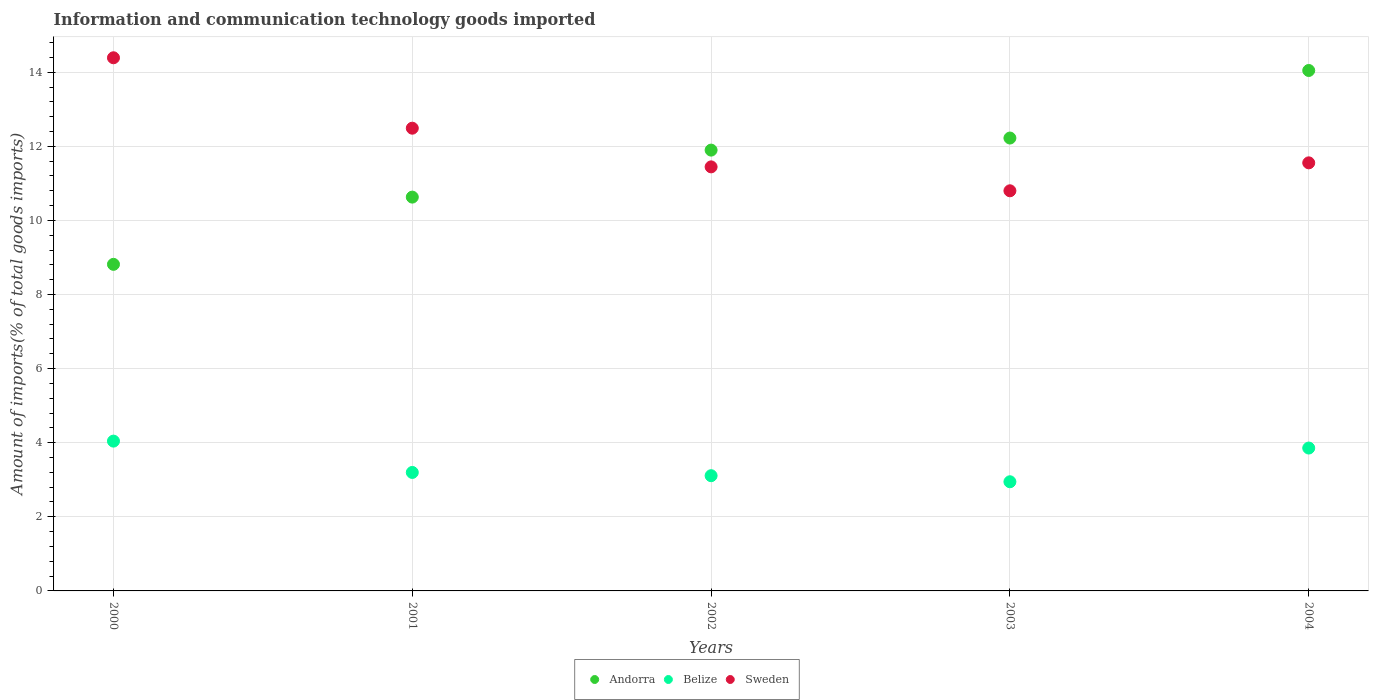Is the number of dotlines equal to the number of legend labels?
Keep it short and to the point. Yes. What is the amount of goods imported in Belize in 2003?
Your response must be concise. 2.95. Across all years, what is the maximum amount of goods imported in Andorra?
Keep it short and to the point. 14.05. Across all years, what is the minimum amount of goods imported in Andorra?
Give a very brief answer. 8.81. In which year was the amount of goods imported in Belize maximum?
Your answer should be compact. 2000. What is the total amount of goods imported in Andorra in the graph?
Your response must be concise. 57.61. What is the difference between the amount of goods imported in Belize in 2000 and that in 2004?
Offer a terse response. 0.19. What is the difference between the amount of goods imported in Belize in 2004 and the amount of goods imported in Andorra in 2000?
Offer a very short reply. -4.96. What is the average amount of goods imported in Andorra per year?
Your answer should be compact. 11.52. In the year 2002, what is the difference between the amount of goods imported in Andorra and amount of goods imported in Sweden?
Your answer should be compact. 0.45. In how many years, is the amount of goods imported in Andorra greater than 3.2 %?
Make the answer very short. 5. What is the ratio of the amount of goods imported in Sweden in 2000 to that in 2003?
Ensure brevity in your answer.  1.33. Is the amount of goods imported in Andorra in 2000 less than that in 2004?
Ensure brevity in your answer.  Yes. What is the difference between the highest and the second highest amount of goods imported in Belize?
Give a very brief answer. 0.19. What is the difference between the highest and the lowest amount of goods imported in Sweden?
Your answer should be very brief. 3.59. Does the amount of goods imported in Sweden monotonically increase over the years?
Make the answer very short. No. Is the amount of goods imported in Belize strictly less than the amount of goods imported in Sweden over the years?
Make the answer very short. Yes. How many dotlines are there?
Your answer should be compact. 3. How many years are there in the graph?
Ensure brevity in your answer.  5. What is the difference between two consecutive major ticks on the Y-axis?
Provide a succinct answer. 2. Are the values on the major ticks of Y-axis written in scientific E-notation?
Offer a terse response. No. Does the graph contain any zero values?
Provide a succinct answer. No. Does the graph contain grids?
Offer a very short reply. Yes. Where does the legend appear in the graph?
Ensure brevity in your answer.  Bottom center. What is the title of the graph?
Provide a succinct answer. Information and communication technology goods imported. What is the label or title of the X-axis?
Your answer should be compact. Years. What is the label or title of the Y-axis?
Your answer should be compact. Amount of imports(% of total goods imports). What is the Amount of imports(% of total goods imports) in Andorra in 2000?
Ensure brevity in your answer.  8.81. What is the Amount of imports(% of total goods imports) of Belize in 2000?
Your answer should be very brief. 4.04. What is the Amount of imports(% of total goods imports) of Sweden in 2000?
Keep it short and to the point. 14.39. What is the Amount of imports(% of total goods imports) in Andorra in 2001?
Keep it short and to the point. 10.63. What is the Amount of imports(% of total goods imports) of Belize in 2001?
Your response must be concise. 3.2. What is the Amount of imports(% of total goods imports) in Sweden in 2001?
Offer a very short reply. 12.49. What is the Amount of imports(% of total goods imports) in Andorra in 2002?
Your response must be concise. 11.9. What is the Amount of imports(% of total goods imports) in Belize in 2002?
Offer a terse response. 3.11. What is the Amount of imports(% of total goods imports) in Sweden in 2002?
Provide a succinct answer. 11.45. What is the Amount of imports(% of total goods imports) in Andorra in 2003?
Your response must be concise. 12.22. What is the Amount of imports(% of total goods imports) of Belize in 2003?
Ensure brevity in your answer.  2.95. What is the Amount of imports(% of total goods imports) of Sweden in 2003?
Give a very brief answer. 10.8. What is the Amount of imports(% of total goods imports) in Andorra in 2004?
Your response must be concise. 14.05. What is the Amount of imports(% of total goods imports) of Belize in 2004?
Give a very brief answer. 3.86. What is the Amount of imports(% of total goods imports) of Sweden in 2004?
Ensure brevity in your answer.  11.55. Across all years, what is the maximum Amount of imports(% of total goods imports) in Andorra?
Keep it short and to the point. 14.05. Across all years, what is the maximum Amount of imports(% of total goods imports) of Belize?
Give a very brief answer. 4.04. Across all years, what is the maximum Amount of imports(% of total goods imports) in Sweden?
Your answer should be compact. 14.39. Across all years, what is the minimum Amount of imports(% of total goods imports) in Andorra?
Your answer should be very brief. 8.81. Across all years, what is the minimum Amount of imports(% of total goods imports) in Belize?
Keep it short and to the point. 2.95. Across all years, what is the minimum Amount of imports(% of total goods imports) of Sweden?
Your answer should be very brief. 10.8. What is the total Amount of imports(% of total goods imports) of Andorra in the graph?
Ensure brevity in your answer.  57.61. What is the total Amount of imports(% of total goods imports) of Belize in the graph?
Offer a very short reply. 17.15. What is the total Amount of imports(% of total goods imports) in Sweden in the graph?
Give a very brief answer. 60.68. What is the difference between the Amount of imports(% of total goods imports) of Andorra in 2000 and that in 2001?
Give a very brief answer. -1.81. What is the difference between the Amount of imports(% of total goods imports) in Belize in 2000 and that in 2001?
Ensure brevity in your answer.  0.85. What is the difference between the Amount of imports(% of total goods imports) in Sweden in 2000 and that in 2001?
Make the answer very short. 1.9. What is the difference between the Amount of imports(% of total goods imports) in Andorra in 2000 and that in 2002?
Give a very brief answer. -3.08. What is the difference between the Amount of imports(% of total goods imports) in Sweden in 2000 and that in 2002?
Your answer should be very brief. 2.94. What is the difference between the Amount of imports(% of total goods imports) in Andorra in 2000 and that in 2003?
Make the answer very short. -3.41. What is the difference between the Amount of imports(% of total goods imports) of Belize in 2000 and that in 2003?
Your answer should be very brief. 1.1. What is the difference between the Amount of imports(% of total goods imports) of Sweden in 2000 and that in 2003?
Your answer should be very brief. 3.59. What is the difference between the Amount of imports(% of total goods imports) in Andorra in 2000 and that in 2004?
Provide a short and direct response. -5.23. What is the difference between the Amount of imports(% of total goods imports) of Belize in 2000 and that in 2004?
Give a very brief answer. 0.19. What is the difference between the Amount of imports(% of total goods imports) in Sweden in 2000 and that in 2004?
Your answer should be compact. 2.84. What is the difference between the Amount of imports(% of total goods imports) of Andorra in 2001 and that in 2002?
Offer a terse response. -1.27. What is the difference between the Amount of imports(% of total goods imports) in Belize in 2001 and that in 2002?
Ensure brevity in your answer.  0.09. What is the difference between the Amount of imports(% of total goods imports) of Sweden in 2001 and that in 2002?
Make the answer very short. 1.04. What is the difference between the Amount of imports(% of total goods imports) in Andorra in 2001 and that in 2003?
Provide a short and direct response. -1.59. What is the difference between the Amount of imports(% of total goods imports) in Belize in 2001 and that in 2003?
Give a very brief answer. 0.25. What is the difference between the Amount of imports(% of total goods imports) of Sweden in 2001 and that in 2003?
Provide a short and direct response. 1.69. What is the difference between the Amount of imports(% of total goods imports) in Andorra in 2001 and that in 2004?
Make the answer very short. -3.42. What is the difference between the Amount of imports(% of total goods imports) in Belize in 2001 and that in 2004?
Ensure brevity in your answer.  -0.66. What is the difference between the Amount of imports(% of total goods imports) in Sweden in 2001 and that in 2004?
Your answer should be very brief. 0.94. What is the difference between the Amount of imports(% of total goods imports) in Andorra in 2002 and that in 2003?
Ensure brevity in your answer.  -0.33. What is the difference between the Amount of imports(% of total goods imports) in Belize in 2002 and that in 2003?
Keep it short and to the point. 0.16. What is the difference between the Amount of imports(% of total goods imports) in Sweden in 2002 and that in 2003?
Provide a succinct answer. 0.65. What is the difference between the Amount of imports(% of total goods imports) of Andorra in 2002 and that in 2004?
Make the answer very short. -2.15. What is the difference between the Amount of imports(% of total goods imports) in Belize in 2002 and that in 2004?
Keep it short and to the point. -0.75. What is the difference between the Amount of imports(% of total goods imports) in Sweden in 2002 and that in 2004?
Give a very brief answer. -0.11. What is the difference between the Amount of imports(% of total goods imports) of Andorra in 2003 and that in 2004?
Make the answer very short. -1.82. What is the difference between the Amount of imports(% of total goods imports) of Belize in 2003 and that in 2004?
Provide a short and direct response. -0.91. What is the difference between the Amount of imports(% of total goods imports) of Sweden in 2003 and that in 2004?
Keep it short and to the point. -0.75. What is the difference between the Amount of imports(% of total goods imports) in Andorra in 2000 and the Amount of imports(% of total goods imports) in Belize in 2001?
Provide a succinct answer. 5.62. What is the difference between the Amount of imports(% of total goods imports) in Andorra in 2000 and the Amount of imports(% of total goods imports) in Sweden in 2001?
Your response must be concise. -3.67. What is the difference between the Amount of imports(% of total goods imports) of Belize in 2000 and the Amount of imports(% of total goods imports) of Sweden in 2001?
Give a very brief answer. -8.45. What is the difference between the Amount of imports(% of total goods imports) of Andorra in 2000 and the Amount of imports(% of total goods imports) of Belize in 2002?
Keep it short and to the point. 5.7. What is the difference between the Amount of imports(% of total goods imports) of Andorra in 2000 and the Amount of imports(% of total goods imports) of Sweden in 2002?
Give a very brief answer. -2.63. What is the difference between the Amount of imports(% of total goods imports) in Belize in 2000 and the Amount of imports(% of total goods imports) in Sweden in 2002?
Ensure brevity in your answer.  -7.4. What is the difference between the Amount of imports(% of total goods imports) in Andorra in 2000 and the Amount of imports(% of total goods imports) in Belize in 2003?
Give a very brief answer. 5.87. What is the difference between the Amount of imports(% of total goods imports) of Andorra in 2000 and the Amount of imports(% of total goods imports) of Sweden in 2003?
Give a very brief answer. -1.99. What is the difference between the Amount of imports(% of total goods imports) of Belize in 2000 and the Amount of imports(% of total goods imports) of Sweden in 2003?
Make the answer very short. -6.76. What is the difference between the Amount of imports(% of total goods imports) in Andorra in 2000 and the Amount of imports(% of total goods imports) in Belize in 2004?
Give a very brief answer. 4.96. What is the difference between the Amount of imports(% of total goods imports) of Andorra in 2000 and the Amount of imports(% of total goods imports) of Sweden in 2004?
Ensure brevity in your answer.  -2.74. What is the difference between the Amount of imports(% of total goods imports) of Belize in 2000 and the Amount of imports(% of total goods imports) of Sweden in 2004?
Make the answer very short. -7.51. What is the difference between the Amount of imports(% of total goods imports) in Andorra in 2001 and the Amount of imports(% of total goods imports) in Belize in 2002?
Your response must be concise. 7.52. What is the difference between the Amount of imports(% of total goods imports) of Andorra in 2001 and the Amount of imports(% of total goods imports) of Sweden in 2002?
Your answer should be compact. -0.82. What is the difference between the Amount of imports(% of total goods imports) in Belize in 2001 and the Amount of imports(% of total goods imports) in Sweden in 2002?
Provide a succinct answer. -8.25. What is the difference between the Amount of imports(% of total goods imports) in Andorra in 2001 and the Amount of imports(% of total goods imports) in Belize in 2003?
Your answer should be very brief. 7.68. What is the difference between the Amount of imports(% of total goods imports) of Andorra in 2001 and the Amount of imports(% of total goods imports) of Sweden in 2003?
Make the answer very short. -0.17. What is the difference between the Amount of imports(% of total goods imports) in Belize in 2001 and the Amount of imports(% of total goods imports) in Sweden in 2003?
Your answer should be very brief. -7.6. What is the difference between the Amount of imports(% of total goods imports) of Andorra in 2001 and the Amount of imports(% of total goods imports) of Belize in 2004?
Keep it short and to the point. 6.77. What is the difference between the Amount of imports(% of total goods imports) of Andorra in 2001 and the Amount of imports(% of total goods imports) of Sweden in 2004?
Keep it short and to the point. -0.92. What is the difference between the Amount of imports(% of total goods imports) of Belize in 2001 and the Amount of imports(% of total goods imports) of Sweden in 2004?
Provide a short and direct response. -8.36. What is the difference between the Amount of imports(% of total goods imports) of Andorra in 2002 and the Amount of imports(% of total goods imports) of Belize in 2003?
Give a very brief answer. 8.95. What is the difference between the Amount of imports(% of total goods imports) of Andorra in 2002 and the Amount of imports(% of total goods imports) of Sweden in 2003?
Your answer should be compact. 1.1. What is the difference between the Amount of imports(% of total goods imports) in Belize in 2002 and the Amount of imports(% of total goods imports) in Sweden in 2003?
Provide a short and direct response. -7.69. What is the difference between the Amount of imports(% of total goods imports) of Andorra in 2002 and the Amount of imports(% of total goods imports) of Belize in 2004?
Offer a very short reply. 8.04. What is the difference between the Amount of imports(% of total goods imports) of Andorra in 2002 and the Amount of imports(% of total goods imports) of Sweden in 2004?
Your answer should be compact. 0.34. What is the difference between the Amount of imports(% of total goods imports) in Belize in 2002 and the Amount of imports(% of total goods imports) in Sweden in 2004?
Your answer should be very brief. -8.44. What is the difference between the Amount of imports(% of total goods imports) in Andorra in 2003 and the Amount of imports(% of total goods imports) in Belize in 2004?
Ensure brevity in your answer.  8.37. What is the difference between the Amount of imports(% of total goods imports) in Andorra in 2003 and the Amount of imports(% of total goods imports) in Sweden in 2004?
Ensure brevity in your answer.  0.67. What is the difference between the Amount of imports(% of total goods imports) in Belize in 2003 and the Amount of imports(% of total goods imports) in Sweden in 2004?
Provide a succinct answer. -8.61. What is the average Amount of imports(% of total goods imports) in Andorra per year?
Your answer should be very brief. 11.52. What is the average Amount of imports(% of total goods imports) in Belize per year?
Your answer should be compact. 3.43. What is the average Amount of imports(% of total goods imports) of Sweden per year?
Provide a succinct answer. 12.14. In the year 2000, what is the difference between the Amount of imports(% of total goods imports) in Andorra and Amount of imports(% of total goods imports) in Belize?
Your answer should be compact. 4.77. In the year 2000, what is the difference between the Amount of imports(% of total goods imports) in Andorra and Amount of imports(% of total goods imports) in Sweden?
Make the answer very short. -5.58. In the year 2000, what is the difference between the Amount of imports(% of total goods imports) in Belize and Amount of imports(% of total goods imports) in Sweden?
Provide a short and direct response. -10.35. In the year 2001, what is the difference between the Amount of imports(% of total goods imports) of Andorra and Amount of imports(% of total goods imports) of Belize?
Provide a succinct answer. 7.43. In the year 2001, what is the difference between the Amount of imports(% of total goods imports) in Andorra and Amount of imports(% of total goods imports) in Sweden?
Your answer should be very brief. -1.86. In the year 2001, what is the difference between the Amount of imports(% of total goods imports) of Belize and Amount of imports(% of total goods imports) of Sweden?
Offer a very short reply. -9.29. In the year 2002, what is the difference between the Amount of imports(% of total goods imports) of Andorra and Amount of imports(% of total goods imports) of Belize?
Offer a very short reply. 8.79. In the year 2002, what is the difference between the Amount of imports(% of total goods imports) of Andorra and Amount of imports(% of total goods imports) of Sweden?
Offer a very short reply. 0.45. In the year 2002, what is the difference between the Amount of imports(% of total goods imports) in Belize and Amount of imports(% of total goods imports) in Sweden?
Offer a terse response. -8.34. In the year 2003, what is the difference between the Amount of imports(% of total goods imports) of Andorra and Amount of imports(% of total goods imports) of Belize?
Provide a succinct answer. 9.28. In the year 2003, what is the difference between the Amount of imports(% of total goods imports) of Andorra and Amount of imports(% of total goods imports) of Sweden?
Provide a short and direct response. 1.42. In the year 2003, what is the difference between the Amount of imports(% of total goods imports) of Belize and Amount of imports(% of total goods imports) of Sweden?
Give a very brief answer. -7.85. In the year 2004, what is the difference between the Amount of imports(% of total goods imports) of Andorra and Amount of imports(% of total goods imports) of Belize?
Give a very brief answer. 10.19. In the year 2004, what is the difference between the Amount of imports(% of total goods imports) of Andorra and Amount of imports(% of total goods imports) of Sweden?
Offer a very short reply. 2.49. In the year 2004, what is the difference between the Amount of imports(% of total goods imports) of Belize and Amount of imports(% of total goods imports) of Sweden?
Offer a very short reply. -7.7. What is the ratio of the Amount of imports(% of total goods imports) in Andorra in 2000 to that in 2001?
Your response must be concise. 0.83. What is the ratio of the Amount of imports(% of total goods imports) in Belize in 2000 to that in 2001?
Provide a short and direct response. 1.26. What is the ratio of the Amount of imports(% of total goods imports) in Sweden in 2000 to that in 2001?
Your answer should be compact. 1.15. What is the ratio of the Amount of imports(% of total goods imports) of Andorra in 2000 to that in 2002?
Keep it short and to the point. 0.74. What is the ratio of the Amount of imports(% of total goods imports) in Belize in 2000 to that in 2002?
Offer a terse response. 1.3. What is the ratio of the Amount of imports(% of total goods imports) in Sweden in 2000 to that in 2002?
Keep it short and to the point. 1.26. What is the ratio of the Amount of imports(% of total goods imports) of Andorra in 2000 to that in 2003?
Your response must be concise. 0.72. What is the ratio of the Amount of imports(% of total goods imports) in Belize in 2000 to that in 2003?
Provide a short and direct response. 1.37. What is the ratio of the Amount of imports(% of total goods imports) of Sweden in 2000 to that in 2003?
Your answer should be very brief. 1.33. What is the ratio of the Amount of imports(% of total goods imports) of Andorra in 2000 to that in 2004?
Provide a succinct answer. 0.63. What is the ratio of the Amount of imports(% of total goods imports) in Belize in 2000 to that in 2004?
Keep it short and to the point. 1.05. What is the ratio of the Amount of imports(% of total goods imports) of Sweden in 2000 to that in 2004?
Provide a succinct answer. 1.25. What is the ratio of the Amount of imports(% of total goods imports) in Andorra in 2001 to that in 2002?
Keep it short and to the point. 0.89. What is the ratio of the Amount of imports(% of total goods imports) in Belize in 2001 to that in 2002?
Make the answer very short. 1.03. What is the ratio of the Amount of imports(% of total goods imports) of Sweden in 2001 to that in 2002?
Give a very brief answer. 1.09. What is the ratio of the Amount of imports(% of total goods imports) in Andorra in 2001 to that in 2003?
Provide a short and direct response. 0.87. What is the ratio of the Amount of imports(% of total goods imports) in Belize in 2001 to that in 2003?
Offer a very short reply. 1.09. What is the ratio of the Amount of imports(% of total goods imports) of Sweden in 2001 to that in 2003?
Provide a short and direct response. 1.16. What is the ratio of the Amount of imports(% of total goods imports) in Andorra in 2001 to that in 2004?
Your response must be concise. 0.76. What is the ratio of the Amount of imports(% of total goods imports) in Belize in 2001 to that in 2004?
Make the answer very short. 0.83. What is the ratio of the Amount of imports(% of total goods imports) in Sweden in 2001 to that in 2004?
Your response must be concise. 1.08. What is the ratio of the Amount of imports(% of total goods imports) of Andorra in 2002 to that in 2003?
Your answer should be very brief. 0.97. What is the ratio of the Amount of imports(% of total goods imports) in Belize in 2002 to that in 2003?
Provide a succinct answer. 1.06. What is the ratio of the Amount of imports(% of total goods imports) in Sweden in 2002 to that in 2003?
Give a very brief answer. 1.06. What is the ratio of the Amount of imports(% of total goods imports) of Andorra in 2002 to that in 2004?
Keep it short and to the point. 0.85. What is the ratio of the Amount of imports(% of total goods imports) in Belize in 2002 to that in 2004?
Provide a succinct answer. 0.81. What is the ratio of the Amount of imports(% of total goods imports) of Sweden in 2002 to that in 2004?
Ensure brevity in your answer.  0.99. What is the ratio of the Amount of imports(% of total goods imports) of Andorra in 2003 to that in 2004?
Give a very brief answer. 0.87. What is the ratio of the Amount of imports(% of total goods imports) of Belize in 2003 to that in 2004?
Provide a succinct answer. 0.76. What is the ratio of the Amount of imports(% of total goods imports) of Sweden in 2003 to that in 2004?
Your answer should be compact. 0.93. What is the difference between the highest and the second highest Amount of imports(% of total goods imports) of Andorra?
Your answer should be compact. 1.82. What is the difference between the highest and the second highest Amount of imports(% of total goods imports) in Belize?
Your response must be concise. 0.19. What is the difference between the highest and the second highest Amount of imports(% of total goods imports) of Sweden?
Ensure brevity in your answer.  1.9. What is the difference between the highest and the lowest Amount of imports(% of total goods imports) of Andorra?
Make the answer very short. 5.23. What is the difference between the highest and the lowest Amount of imports(% of total goods imports) in Belize?
Give a very brief answer. 1.1. What is the difference between the highest and the lowest Amount of imports(% of total goods imports) of Sweden?
Make the answer very short. 3.59. 